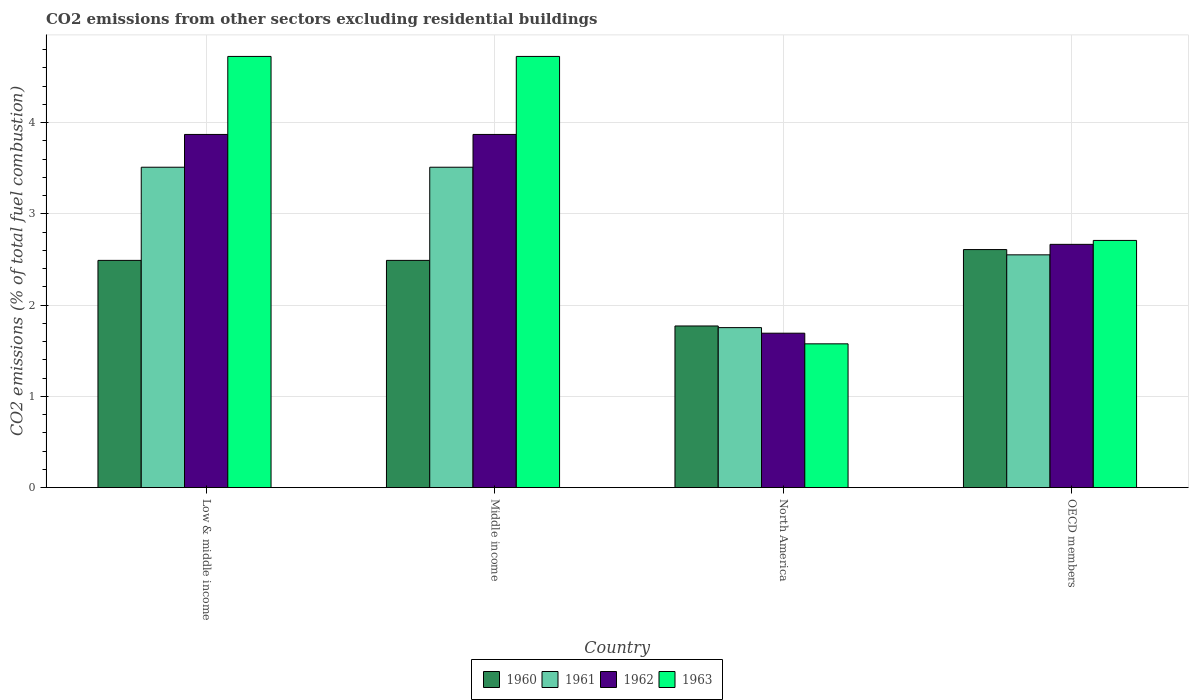How many different coloured bars are there?
Your response must be concise. 4. Are the number of bars per tick equal to the number of legend labels?
Provide a short and direct response. Yes. Are the number of bars on each tick of the X-axis equal?
Give a very brief answer. Yes. How many bars are there on the 4th tick from the left?
Your answer should be compact. 4. How many bars are there on the 3rd tick from the right?
Provide a short and direct response. 4. What is the label of the 2nd group of bars from the left?
Make the answer very short. Middle income. In how many cases, is the number of bars for a given country not equal to the number of legend labels?
Give a very brief answer. 0. What is the total CO2 emitted in 1960 in Middle income?
Provide a short and direct response. 2.49. Across all countries, what is the maximum total CO2 emitted in 1962?
Provide a short and direct response. 3.87. Across all countries, what is the minimum total CO2 emitted in 1962?
Your response must be concise. 1.69. In which country was the total CO2 emitted in 1960 minimum?
Your answer should be very brief. North America. What is the total total CO2 emitted in 1961 in the graph?
Ensure brevity in your answer.  11.33. What is the difference between the total CO2 emitted in 1962 in Low & middle income and that in Middle income?
Keep it short and to the point. 0. What is the difference between the total CO2 emitted in 1961 in OECD members and the total CO2 emitted in 1963 in North America?
Make the answer very short. 0.98. What is the average total CO2 emitted in 1962 per country?
Make the answer very short. 3.03. What is the difference between the total CO2 emitted of/in 1962 and total CO2 emitted of/in 1960 in Low & middle income?
Offer a terse response. 1.38. In how many countries, is the total CO2 emitted in 1963 greater than 4.2?
Provide a succinct answer. 2. What is the ratio of the total CO2 emitted in 1963 in Low & middle income to that in OECD members?
Provide a short and direct response. 1.74. Is the total CO2 emitted in 1960 in Low & middle income less than that in North America?
Offer a very short reply. No. What is the difference between the highest and the second highest total CO2 emitted in 1961?
Your response must be concise. -0.96. What is the difference between the highest and the lowest total CO2 emitted in 1961?
Your response must be concise. 1.76. Is the sum of the total CO2 emitted in 1960 in Middle income and North America greater than the maximum total CO2 emitted in 1963 across all countries?
Offer a very short reply. No. What does the 3rd bar from the left in Low & middle income represents?
Provide a short and direct response. 1962. Is it the case that in every country, the sum of the total CO2 emitted in 1961 and total CO2 emitted in 1963 is greater than the total CO2 emitted in 1962?
Make the answer very short. Yes. How many bars are there?
Ensure brevity in your answer.  16. Are all the bars in the graph horizontal?
Provide a short and direct response. No. How many countries are there in the graph?
Make the answer very short. 4. What is the difference between two consecutive major ticks on the Y-axis?
Your response must be concise. 1. Are the values on the major ticks of Y-axis written in scientific E-notation?
Offer a very short reply. No. Does the graph contain any zero values?
Provide a short and direct response. No. Does the graph contain grids?
Your answer should be compact. Yes. Where does the legend appear in the graph?
Ensure brevity in your answer.  Bottom center. What is the title of the graph?
Provide a succinct answer. CO2 emissions from other sectors excluding residential buildings. Does "1977" appear as one of the legend labels in the graph?
Offer a very short reply. No. What is the label or title of the Y-axis?
Make the answer very short. CO2 emissions (% of total fuel combustion). What is the CO2 emissions (% of total fuel combustion) of 1960 in Low & middle income?
Provide a succinct answer. 2.49. What is the CO2 emissions (% of total fuel combustion) in 1961 in Low & middle income?
Offer a terse response. 3.51. What is the CO2 emissions (% of total fuel combustion) in 1962 in Low & middle income?
Keep it short and to the point. 3.87. What is the CO2 emissions (% of total fuel combustion) of 1963 in Low & middle income?
Your answer should be compact. 4.73. What is the CO2 emissions (% of total fuel combustion) of 1960 in Middle income?
Make the answer very short. 2.49. What is the CO2 emissions (% of total fuel combustion) of 1961 in Middle income?
Your answer should be compact. 3.51. What is the CO2 emissions (% of total fuel combustion) in 1962 in Middle income?
Offer a very short reply. 3.87. What is the CO2 emissions (% of total fuel combustion) of 1963 in Middle income?
Your answer should be compact. 4.73. What is the CO2 emissions (% of total fuel combustion) in 1960 in North America?
Ensure brevity in your answer.  1.77. What is the CO2 emissions (% of total fuel combustion) of 1961 in North America?
Your response must be concise. 1.75. What is the CO2 emissions (% of total fuel combustion) in 1962 in North America?
Your response must be concise. 1.69. What is the CO2 emissions (% of total fuel combustion) of 1963 in North America?
Make the answer very short. 1.58. What is the CO2 emissions (% of total fuel combustion) in 1960 in OECD members?
Provide a succinct answer. 2.61. What is the CO2 emissions (% of total fuel combustion) in 1961 in OECD members?
Your answer should be very brief. 2.55. What is the CO2 emissions (% of total fuel combustion) in 1962 in OECD members?
Provide a succinct answer. 2.67. What is the CO2 emissions (% of total fuel combustion) in 1963 in OECD members?
Keep it short and to the point. 2.71. Across all countries, what is the maximum CO2 emissions (% of total fuel combustion) of 1960?
Your response must be concise. 2.61. Across all countries, what is the maximum CO2 emissions (% of total fuel combustion) of 1961?
Make the answer very short. 3.51. Across all countries, what is the maximum CO2 emissions (% of total fuel combustion) of 1962?
Provide a succinct answer. 3.87. Across all countries, what is the maximum CO2 emissions (% of total fuel combustion) in 1963?
Ensure brevity in your answer.  4.73. Across all countries, what is the minimum CO2 emissions (% of total fuel combustion) of 1960?
Your answer should be very brief. 1.77. Across all countries, what is the minimum CO2 emissions (% of total fuel combustion) in 1961?
Your response must be concise. 1.75. Across all countries, what is the minimum CO2 emissions (% of total fuel combustion) of 1962?
Provide a succinct answer. 1.69. Across all countries, what is the minimum CO2 emissions (% of total fuel combustion) in 1963?
Keep it short and to the point. 1.58. What is the total CO2 emissions (% of total fuel combustion) of 1960 in the graph?
Offer a very short reply. 9.36. What is the total CO2 emissions (% of total fuel combustion) of 1961 in the graph?
Ensure brevity in your answer.  11.33. What is the total CO2 emissions (% of total fuel combustion) of 1962 in the graph?
Keep it short and to the point. 12.1. What is the total CO2 emissions (% of total fuel combustion) in 1963 in the graph?
Your answer should be very brief. 13.74. What is the difference between the CO2 emissions (% of total fuel combustion) in 1961 in Low & middle income and that in Middle income?
Offer a terse response. 0. What is the difference between the CO2 emissions (% of total fuel combustion) of 1962 in Low & middle income and that in Middle income?
Offer a very short reply. 0. What is the difference between the CO2 emissions (% of total fuel combustion) in 1960 in Low & middle income and that in North America?
Your response must be concise. 0.72. What is the difference between the CO2 emissions (% of total fuel combustion) in 1961 in Low & middle income and that in North America?
Your answer should be compact. 1.76. What is the difference between the CO2 emissions (% of total fuel combustion) in 1962 in Low & middle income and that in North America?
Ensure brevity in your answer.  2.18. What is the difference between the CO2 emissions (% of total fuel combustion) of 1963 in Low & middle income and that in North America?
Give a very brief answer. 3.15. What is the difference between the CO2 emissions (% of total fuel combustion) in 1960 in Low & middle income and that in OECD members?
Give a very brief answer. -0.12. What is the difference between the CO2 emissions (% of total fuel combustion) of 1961 in Low & middle income and that in OECD members?
Ensure brevity in your answer.  0.96. What is the difference between the CO2 emissions (% of total fuel combustion) in 1962 in Low & middle income and that in OECD members?
Provide a short and direct response. 1.2. What is the difference between the CO2 emissions (% of total fuel combustion) in 1963 in Low & middle income and that in OECD members?
Your answer should be very brief. 2.02. What is the difference between the CO2 emissions (% of total fuel combustion) in 1960 in Middle income and that in North America?
Provide a succinct answer. 0.72. What is the difference between the CO2 emissions (% of total fuel combustion) in 1961 in Middle income and that in North America?
Provide a short and direct response. 1.76. What is the difference between the CO2 emissions (% of total fuel combustion) in 1962 in Middle income and that in North America?
Offer a very short reply. 2.18. What is the difference between the CO2 emissions (% of total fuel combustion) of 1963 in Middle income and that in North America?
Ensure brevity in your answer.  3.15. What is the difference between the CO2 emissions (% of total fuel combustion) of 1960 in Middle income and that in OECD members?
Offer a terse response. -0.12. What is the difference between the CO2 emissions (% of total fuel combustion) in 1961 in Middle income and that in OECD members?
Offer a very short reply. 0.96. What is the difference between the CO2 emissions (% of total fuel combustion) of 1962 in Middle income and that in OECD members?
Ensure brevity in your answer.  1.2. What is the difference between the CO2 emissions (% of total fuel combustion) in 1963 in Middle income and that in OECD members?
Your answer should be compact. 2.02. What is the difference between the CO2 emissions (% of total fuel combustion) of 1960 in North America and that in OECD members?
Make the answer very short. -0.84. What is the difference between the CO2 emissions (% of total fuel combustion) of 1961 in North America and that in OECD members?
Give a very brief answer. -0.8. What is the difference between the CO2 emissions (% of total fuel combustion) of 1962 in North America and that in OECD members?
Give a very brief answer. -0.97. What is the difference between the CO2 emissions (% of total fuel combustion) in 1963 in North America and that in OECD members?
Give a very brief answer. -1.13. What is the difference between the CO2 emissions (% of total fuel combustion) of 1960 in Low & middle income and the CO2 emissions (% of total fuel combustion) of 1961 in Middle income?
Your answer should be very brief. -1.02. What is the difference between the CO2 emissions (% of total fuel combustion) in 1960 in Low & middle income and the CO2 emissions (% of total fuel combustion) in 1962 in Middle income?
Your response must be concise. -1.38. What is the difference between the CO2 emissions (% of total fuel combustion) in 1960 in Low & middle income and the CO2 emissions (% of total fuel combustion) in 1963 in Middle income?
Your response must be concise. -2.24. What is the difference between the CO2 emissions (% of total fuel combustion) of 1961 in Low & middle income and the CO2 emissions (% of total fuel combustion) of 1962 in Middle income?
Keep it short and to the point. -0.36. What is the difference between the CO2 emissions (% of total fuel combustion) of 1961 in Low & middle income and the CO2 emissions (% of total fuel combustion) of 1963 in Middle income?
Offer a terse response. -1.21. What is the difference between the CO2 emissions (% of total fuel combustion) in 1962 in Low & middle income and the CO2 emissions (% of total fuel combustion) in 1963 in Middle income?
Give a very brief answer. -0.85. What is the difference between the CO2 emissions (% of total fuel combustion) in 1960 in Low & middle income and the CO2 emissions (% of total fuel combustion) in 1961 in North America?
Keep it short and to the point. 0.74. What is the difference between the CO2 emissions (% of total fuel combustion) in 1960 in Low & middle income and the CO2 emissions (% of total fuel combustion) in 1962 in North America?
Provide a succinct answer. 0.8. What is the difference between the CO2 emissions (% of total fuel combustion) in 1960 in Low & middle income and the CO2 emissions (% of total fuel combustion) in 1963 in North America?
Your answer should be very brief. 0.91. What is the difference between the CO2 emissions (% of total fuel combustion) in 1961 in Low & middle income and the CO2 emissions (% of total fuel combustion) in 1962 in North America?
Provide a short and direct response. 1.82. What is the difference between the CO2 emissions (% of total fuel combustion) in 1961 in Low & middle income and the CO2 emissions (% of total fuel combustion) in 1963 in North America?
Offer a terse response. 1.94. What is the difference between the CO2 emissions (% of total fuel combustion) of 1962 in Low & middle income and the CO2 emissions (% of total fuel combustion) of 1963 in North America?
Offer a very short reply. 2.3. What is the difference between the CO2 emissions (% of total fuel combustion) in 1960 in Low & middle income and the CO2 emissions (% of total fuel combustion) in 1961 in OECD members?
Your answer should be compact. -0.06. What is the difference between the CO2 emissions (% of total fuel combustion) in 1960 in Low & middle income and the CO2 emissions (% of total fuel combustion) in 1962 in OECD members?
Ensure brevity in your answer.  -0.18. What is the difference between the CO2 emissions (% of total fuel combustion) in 1960 in Low & middle income and the CO2 emissions (% of total fuel combustion) in 1963 in OECD members?
Provide a succinct answer. -0.22. What is the difference between the CO2 emissions (% of total fuel combustion) of 1961 in Low & middle income and the CO2 emissions (% of total fuel combustion) of 1962 in OECD members?
Provide a succinct answer. 0.85. What is the difference between the CO2 emissions (% of total fuel combustion) in 1961 in Low & middle income and the CO2 emissions (% of total fuel combustion) in 1963 in OECD members?
Provide a succinct answer. 0.8. What is the difference between the CO2 emissions (% of total fuel combustion) in 1962 in Low & middle income and the CO2 emissions (% of total fuel combustion) in 1963 in OECD members?
Your answer should be very brief. 1.16. What is the difference between the CO2 emissions (% of total fuel combustion) of 1960 in Middle income and the CO2 emissions (% of total fuel combustion) of 1961 in North America?
Your response must be concise. 0.74. What is the difference between the CO2 emissions (% of total fuel combustion) in 1960 in Middle income and the CO2 emissions (% of total fuel combustion) in 1962 in North America?
Your answer should be very brief. 0.8. What is the difference between the CO2 emissions (% of total fuel combustion) in 1960 in Middle income and the CO2 emissions (% of total fuel combustion) in 1963 in North America?
Ensure brevity in your answer.  0.91. What is the difference between the CO2 emissions (% of total fuel combustion) of 1961 in Middle income and the CO2 emissions (% of total fuel combustion) of 1962 in North America?
Offer a very short reply. 1.82. What is the difference between the CO2 emissions (% of total fuel combustion) of 1961 in Middle income and the CO2 emissions (% of total fuel combustion) of 1963 in North America?
Offer a terse response. 1.94. What is the difference between the CO2 emissions (% of total fuel combustion) in 1962 in Middle income and the CO2 emissions (% of total fuel combustion) in 1963 in North America?
Give a very brief answer. 2.3. What is the difference between the CO2 emissions (% of total fuel combustion) of 1960 in Middle income and the CO2 emissions (% of total fuel combustion) of 1961 in OECD members?
Make the answer very short. -0.06. What is the difference between the CO2 emissions (% of total fuel combustion) of 1960 in Middle income and the CO2 emissions (% of total fuel combustion) of 1962 in OECD members?
Offer a terse response. -0.18. What is the difference between the CO2 emissions (% of total fuel combustion) in 1960 in Middle income and the CO2 emissions (% of total fuel combustion) in 1963 in OECD members?
Your response must be concise. -0.22. What is the difference between the CO2 emissions (% of total fuel combustion) of 1961 in Middle income and the CO2 emissions (% of total fuel combustion) of 1962 in OECD members?
Provide a succinct answer. 0.85. What is the difference between the CO2 emissions (% of total fuel combustion) in 1961 in Middle income and the CO2 emissions (% of total fuel combustion) in 1963 in OECD members?
Your answer should be compact. 0.8. What is the difference between the CO2 emissions (% of total fuel combustion) of 1962 in Middle income and the CO2 emissions (% of total fuel combustion) of 1963 in OECD members?
Your answer should be very brief. 1.16. What is the difference between the CO2 emissions (% of total fuel combustion) in 1960 in North America and the CO2 emissions (% of total fuel combustion) in 1961 in OECD members?
Offer a very short reply. -0.78. What is the difference between the CO2 emissions (% of total fuel combustion) of 1960 in North America and the CO2 emissions (% of total fuel combustion) of 1962 in OECD members?
Ensure brevity in your answer.  -0.89. What is the difference between the CO2 emissions (% of total fuel combustion) of 1960 in North America and the CO2 emissions (% of total fuel combustion) of 1963 in OECD members?
Offer a terse response. -0.94. What is the difference between the CO2 emissions (% of total fuel combustion) of 1961 in North America and the CO2 emissions (% of total fuel combustion) of 1962 in OECD members?
Offer a very short reply. -0.91. What is the difference between the CO2 emissions (% of total fuel combustion) of 1961 in North America and the CO2 emissions (% of total fuel combustion) of 1963 in OECD members?
Provide a succinct answer. -0.96. What is the difference between the CO2 emissions (% of total fuel combustion) of 1962 in North America and the CO2 emissions (% of total fuel combustion) of 1963 in OECD members?
Your answer should be very brief. -1.02. What is the average CO2 emissions (% of total fuel combustion) in 1960 per country?
Keep it short and to the point. 2.34. What is the average CO2 emissions (% of total fuel combustion) in 1961 per country?
Your answer should be very brief. 2.83. What is the average CO2 emissions (% of total fuel combustion) of 1962 per country?
Your answer should be very brief. 3.03. What is the average CO2 emissions (% of total fuel combustion) of 1963 per country?
Offer a terse response. 3.43. What is the difference between the CO2 emissions (% of total fuel combustion) in 1960 and CO2 emissions (% of total fuel combustion) in 1961 in Low & middle income?
Your response must be concise. -1.02. What is the difference between the CO2 emissions (% of total fuel combustion) of 1960 and CO2 emissions (% of total fuel combustion) of 1962 in Low & middle income?
Your response must be concise. -1.38. What is the difference between the CO2 emissions (% of total fuel combustion) in 1960 and CO2 emissions (% of total fuel combustion) in 1963 in Low & middle income?
Offer a very short reply. -2.24. What is the difference between the CO2 emissions (% of total fuel combustion) of 1961 and CO2 emissions (% of total fuel combustion) of 1962 in Low & middle income?
Provide a short and direct response. -0.36. What is the difference between the CO2 emissions (% of total fuel combustion) of 1961 and CO2 emissions (% of total fuel combustion) of 1963 in Low & middle income?
Provide a short and direct response. -1.21. What is the difference between the CO2 emissions (% of total fuel combustion) of 1962 and CO2 emissions (% of total fuel combustion) of 1963 in Low & middle income?
Keep it short and to the point. -0.85. What is the difference between the CO2 emissions (% of total fuel combustion) in 1960 and CO2 emissions (% of total fuel combustion) in 1961 in Middle income?
Offer a very short reply. -1.02. What is the difference between the CO2 emissions (% of total fuel combustion) of 1960 and CO2 emissions (% of total fuel combustion) of 1962 in Middle income?
Your answer should be compact. -1.38. What is the difference between the CO2 emissions (% of total fuel combustion) of 1960 and CO2 emissions (% of total fuel combustion) of 1963 in Middle income?
Ensure brevity in your answer.  -2.24. What is the difference between the CO2 emissions (% of total fuel combustion) in 1961 and CO2 emissions (% of total fuel combustion) in 1962 in Middle income?
Keep it short and to the point. -0.36. What is the difference between the CO2 emissions (% of total fuel combustion) in 1961 and CO2 emissions (% of total fuel combustion) in 1963 in Middle income?
Your answer should be compact. -1.21. What is the difference between the CO2 emissions (% of total fuel combustion) of 1962 and CO2 emissions (% of total fuel combustion) of 1963 in Middle income?
Give a very brief answer. -0.85. What is the difference between the CO2 emissions (% of total fuel combustion) of 1960 and CO2 emissions (% of total fuel combustion) of 1961 in North America?
Your answer should be very brief. 0.02. What is the difference between the CO2 emissions (% of total fuel combustion) in 1960 and CO2 emissions (% of total fuel combustion) in 1962 in North America?
Your answer should be very brief. 0.08. What is the difference between the CO2 emissions (% of total fuel combustion) in 1960 and CO2 emissions (% of total fuel combustion) in 1963 in North America?
Provide a succinct answer. 0.2. What is the difference between the CO2 emissions (% of total fuel combustion) in 1961 and CO2 emissions (% of total fuel combustion) in 1962 in North America?
Your answer should be very brief. 0.06. What is the difference between the CO2 emissions (% of total fuel combustion) of 1961 and CO2 emissions (% of total fuel combustion) of 1963 in North America?
Make the answer very short. 0.18. What is the difference between the CO2 emissions (% of total fuel combustion) in 1962 and CO2 emissions (% of total fuel combustion) in 1963 in North America?
Your answer should be very brief. 0.12. What is the difference between the CO2 emissions (% of total fuel combustion) of 1960 and CO2 emissions (% of total fuel combustion) of 1961 in OECD members?
Your answer should be compact. 0.06. What is the difference between the CO2 emissions (% of total fuel combustion) in 1960 and CO2 emissions (% of total fuel combustion) in 1962 in OECD members?
Give a very brief answer. -0.06. What is the difference between the CO2 emissions (% of total fuel combustion) in 1960 and CO2 emissions (% of total fuel combustion) in 1963 in OECD members?
Your response must be concise. -0.1. What is the difference between the CO2 emissions (% of total fuel combustion) of 1961 and CO2 emissions (% of total fuel combustion) of 1962 in OECD members?
Make the answer very short. -0.12. What is the difference between the CO2 emissions (% of total fuel combustion) in 1961 and CO2 emissions (% of total fuel combustion) in 1963 in OECD members?
Provide a short and direct response. -0.16. What is the difference between the CO2 emissions (% of total fuel combustion) in 1962 and CO2 emissions (% of total fuel combustion) in 1963 in OECD members?
Offer a terse response. -0.04. What is the ratio of the CO2 emissions (% of total fuel combustion) in 1961 in Low & middle income to that in Middle income?
Keep it short and to the point. 1. What is the ratio of the CO2 emissions (% of total fuel combustion) of 1962 in Low & middle income to that in Middle income?
Ensure brevity in your answer.  1. What is the ratio of the CO2 emissions (% of total fuel combustion) in 1963 in Low & middle income to that in Middle income?
Keep it short and to the point. 1. What is the ratio of the CO2 emissions (% of total fuel combustion) in 1960 in Low & middle income to that in North America?
Make the answer very short. 1.41. What is the ratio of the CO2 emissions (% of total fuel combustion) of 1961 in Low & middle income to that in North America?
Keep it short and to the point. 2. What is the ratio of the CO2 emissions (% of total fuel combustion) in 1962 in Low & middle income to that in North America?
Your answer should be very brief. 2.29. What is the ratio of the CO2 emissions (% of total fuel combustion) in 1963 in Low & middle income to that in North America?
Make the answer very short. 3. What is the ratio of the CO2 emissions (% of total fuel combustion) in 1960 in Low & middle income to that in OECD members?
Your response must be concise. 0.95. What is the ratio of the CO2 emissions (% of total fuel combustion) of 1961 in Low & middle income to that in OECD members?
Ensure brevity in your answer.  1.38. What is the ratio of the CO2 emissions (% of total fuel combustion) in 1962 in Low & middle income to that in OECD members?
Provide a short and direct response. 1.45. What is the ratio of the CO2 emissions (% of total fuel combustion) of 1963 in Low & middle income to that in OECD members?
Your response must be concise. 1.74. What is the ratio of the CO2 emissions (% of total fuel combustion) of 1960 in Middle income to that in North America?
Your answer should be very brief. 1.41. What is the ratio of the CO2 emissions (% of total fuel combustion) in 1961 in Middle income to that in North America?
Your answer should be compact. 2. What is the ratio of the CO2 emissions (% of total fuel combustion) of 1962 in Middle income to that in North America?
Your answer should be very brief. 2.29. What is the ratio of the CO2 emissions (% of total fuel combustion) of 1963 in Middle income to that in North America?
Provide a succinct answer. 3. What is the ratio of the CO2 emissions (% of total fuel combustion) of 1960 in Middle income to that in OECD members?
Provide a succinct answer. 0.95. What is the ratio of the CO2 emissions (% of total fuel combustion) in 1961 in Middle income to that in OECD members?
Your answer should be compact. 1.38. What is the ratio of the CO2 emissions (% of total fuel combustion) in 1962 in Middle income to that in OECD members?
Make the answer very short. 1.45. What is the ratio of the CO2 emissions (% of total fuel combustion) in 1963 in Middle income to that in OECD members?
Give a very brief answer. 1.74. What is the ratio of the CO2 emissions (% of total fuel combustion) of 1960 in North America to that in OECD members?
Your answer should be very brief. 0.68. What is the ratio of the CO2 emissions (% of total fuel combustion) in 1961 in North America to that in OECD members?
Provide a short and direct response. 0.69. What is the ratio of the CO2 emissions (% of total fuel combustion) of 1962 in North America to that in OECD members?
Your answer should be compact. 0.63. What is the ratio of the CO2 emissions (% of total fuel combustion) of 1963 in North America to that in OECD members?
Your response must be concise. 0.58. What is the difference between the highest and the second highest CO2 emissions (% of total fuel combustion) in 1960?
Keep it short and to the point. 0.12. What is the difference between the highest and the second highest CO2 emissions (% of total fuel combustion) in 1961?
Offer a very short reply. 0. What is the difference between the highest and the second highest CO2 emissions (% of total fuel combustion) in 1962?
Ensure brevity in your answer.  0. What is the difference between the highest and the second highest CO2 emissions (% of total fuel combustion) of 1963?
Keep it short and to the point. 0. What is the difference between the highest and the lowest CO2 emissions (% of total fuel combustion) in 1960?
Ensure brevity in your answer.  0.84. What is the difference between the highest and the lowest CO2 emissions (% of total fuel combustion) of 1961?
Your response must be concise. 1.76. What is the difference between the highest and the lowest CO2 emissions (% of total fuel combustion) of 1962?
Provide a succinct answer. 2.18. What is the difference between the highest and the lowest CO2 emissions (% of total fuel combustion) in 1963?
Ensure brevity in your answer.  3.15. 